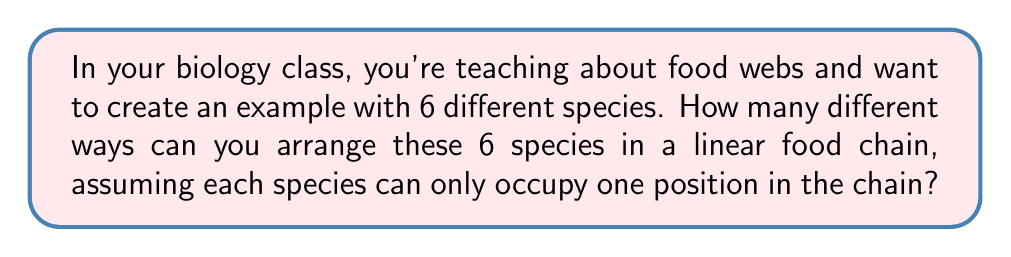Give your solution to this math problem. Let's approach this step-by-step:

1) In this problem, we're essentially asking how many ways we can arrange 6 distinct objects (species) in a line.

2) This is a classic permutation problem. We're arranging all 6 species, and the order matters (as it's a food chain).

3) The formula for permutations of n distinct objects is:

   $$P(n) = n!$$

   Where $n!$ represents the factorial of $n$.

4) In this case, $n = 6$, so we need to calculate $6!$:

   $$6! = 6 \times 5 \times 4 \times 3 \times 2 \times 1$$

5) Let's compute this:
   
   $$6! = 6 \times 5 \times 4 \times 3 \times 2 \times 1 = 720$$

6) Therefore, there are 720 different ways to arrange 6 different species in a linear food chain.

This concept can help students understand the complexity of food webs in ecosystems, as even a small number of species can create numerous possible arrangements.
Answer: 720 